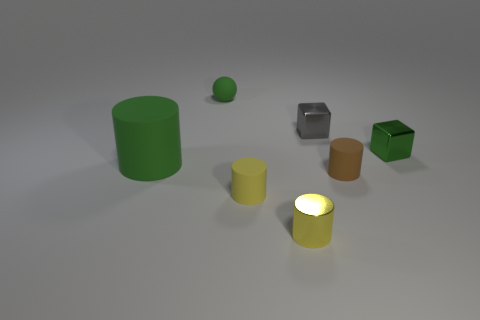How many objects are there in total? There are six objects in total, including one large green cylinder, a smaller green sphere, a metallic cube, a green cube, and two cylindrical objects that are yellow and brown, respectively. 